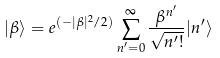<formula> <loc_0><loc_0><loc_500><loc_500>| \beta \rangle = e ^ { ( - | \beta | ^ { 2 } / 2 ) } \sum _ { n ^ { \prime } = 0 } ^ { \infty } \frac { \beta ^ { n ^ { \prime } } } { \sqrt { n ^ { \prime } ! } } | n ^ { \prime } \rangle</formula> 